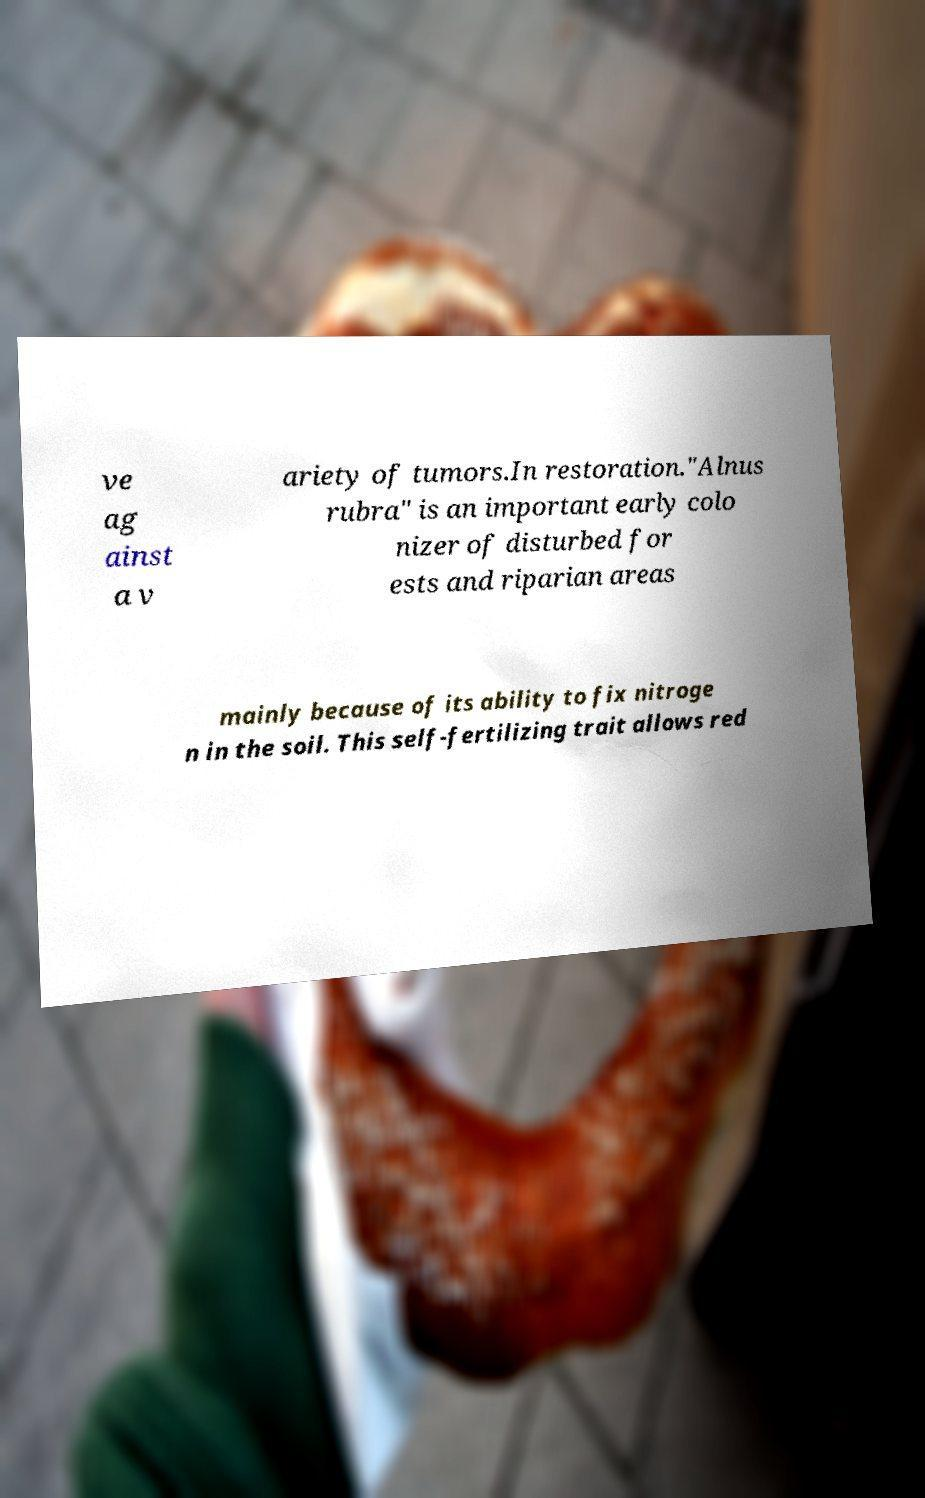Could you assist in decoding the text presented in this image and type it out clearly? ve ag ainst a v ariety of tumors.In restoration."Alnus rubra" is an important early colo nizer of disturbed for ests and riparian areas mainly because of its ability to fix nitroge n in the soil. This self-fertilizing trait allows red 